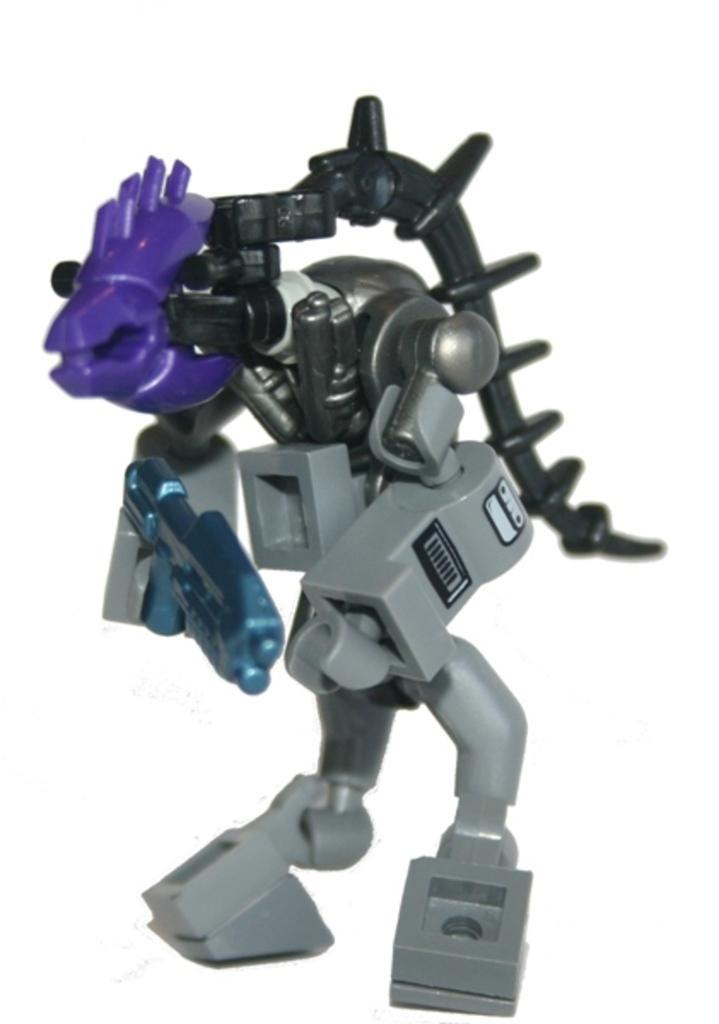What object can be seen in the image? There is a toy in the image. What color is the background of the image? The background of the image is white. Is there a carriage in the image? No, there is no carriage present in the image. Is there a bulb emitting light in the image? No, there is no bulb present in the image. 